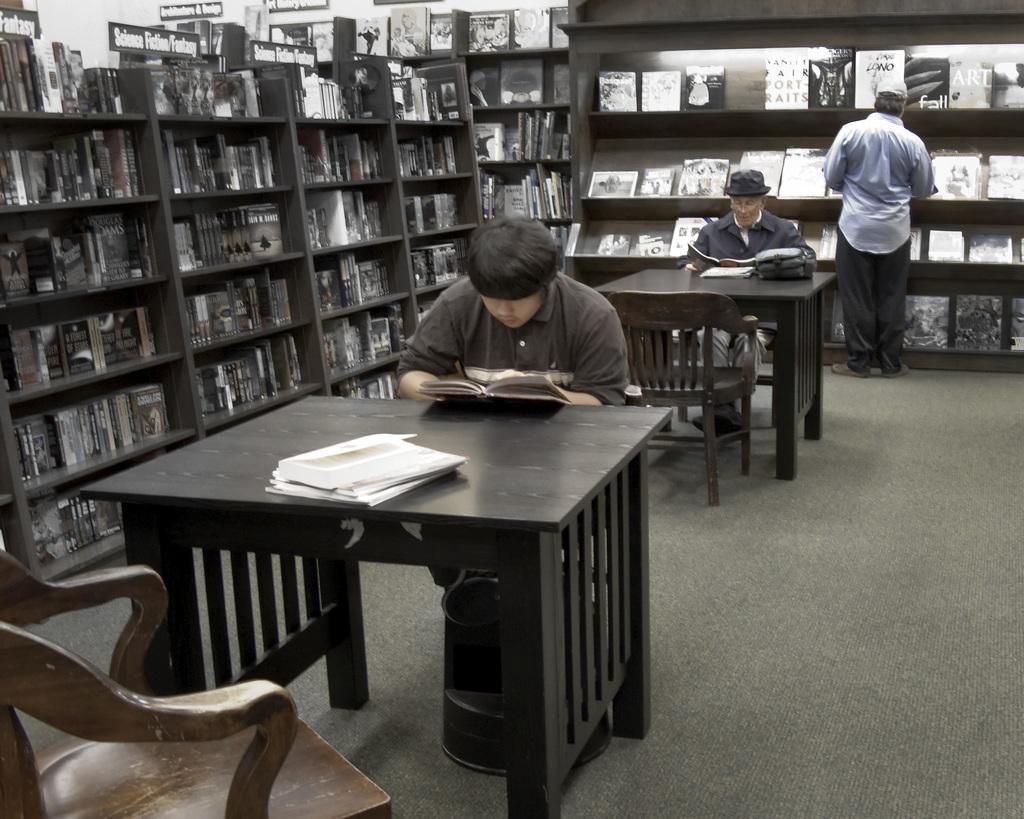How would you summarize this image in a sentence or two? In this image I can see three men among them two are sitting on a chair in front of the table and reading books and the person on the last is standing on the floor. Here we have a shelf with books on them. In the front of the image we have a chair, couple of books on the table. 